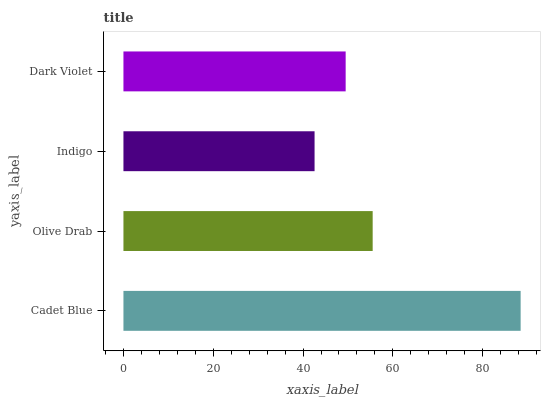Is Indigo the minimum?
Answer yes or no. Yes. Is Cadet Blue the maximum?
Answer yes or no. Yes. Is Olive Drab the minimum?
Answer yes or no. No. Is Olive Drab the maximum?
Answer yes or no. No. Is Cadet Blue greater than Olive Drab?
Answer yes or no. Yes. Is Olive Drab less than Cadet Blue?
Answer yes or no. Yes. Is Olive Drab greater than Cadet Blue?
Answer yes or no. No. Is Cadet Blue less than Olive Drab?
Answer yes or no. No. Is Olive Drab the high median?
Answer yes or no. Yes. Is Dark Violet the low median?
Answer yes or no. Yes. Is Indigo the high median?
Answer yes or no. No. Is Olive Drab the low median?
Answer yes or no. No. 